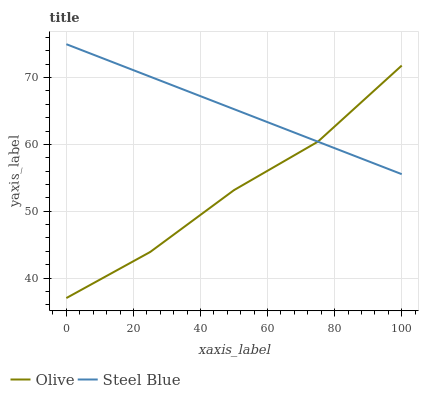Does Olive have the minimum area under the curve?
Answer yes or no. Yes. Does Steel Blue have the maximum area under the curve?
Answer yes or no. Yes. Does Steel Blue have the minimum area under the curve?
Answer yes or no. No. Is Steel Blue the smoothest?
Answer yes or no. Yes. Is Olive the roughest?
Answer yes or no. Yes. Is Steel Blue the roughest?
Answer yes or no. No. Does Olive have the lowest value?
Answer yes or no. Yes. Does Steel Blue have the lowest value?
Answer yes or no. No. Does Steel Blue have the highest value?
Answer yes or no. Yes. Does Olive intersect Steel Blue?
Answer yes or no. Yes. Is Olive less than Steel Blue?
Answer yes or no. No. Is Olive greater than Steel Blue?
Answer yes or no. No. 